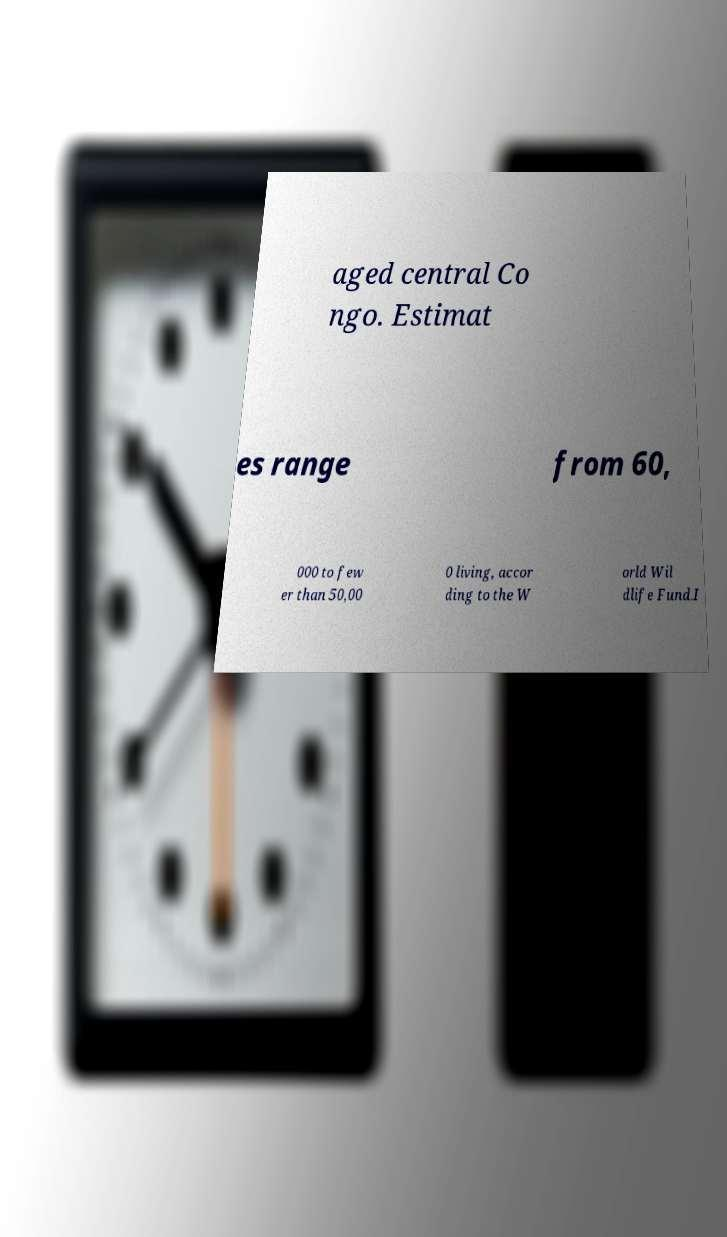There's text embedded in this image that I need extracted. Can you transcribe it verbatim? aged central Co ngo. Estimat es range from 60, 000 to few er than 50,00 0 living, accor ding to the W orld Wil dlife Fund.I 